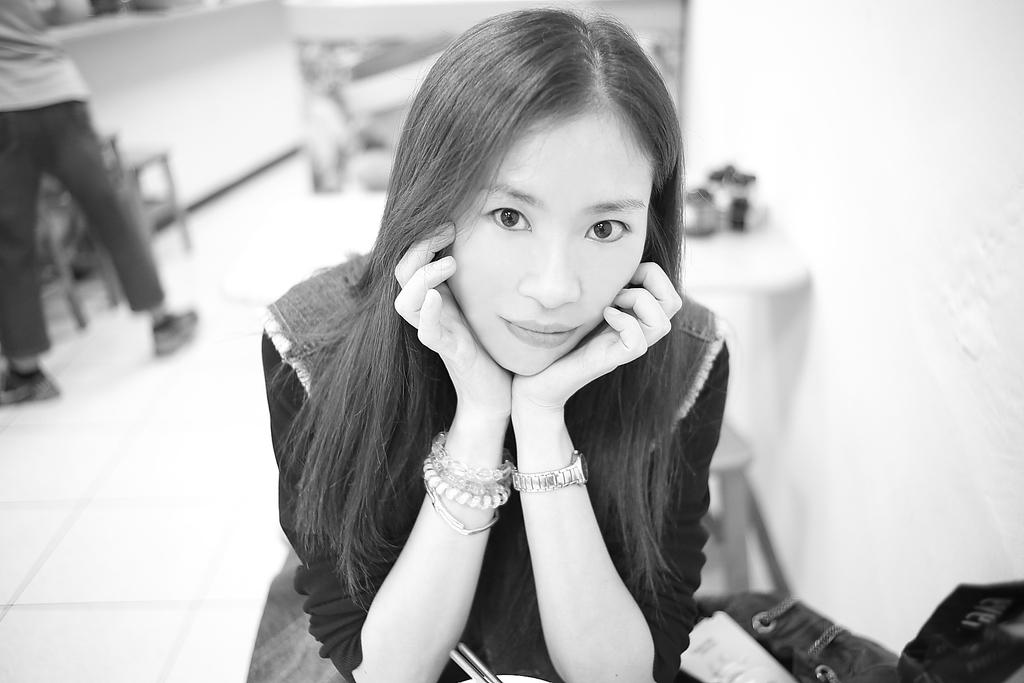Who is the main subject in the image? There is a girl in the center of the image. Can you describe the other person in the image? There is a man on the left side of the image. What can be observed about the background of the image? The background area of the image is blurred. What type of flowers can be seen in the image? There are no flowers present in the image. What time of day is depicted in the image? The time of day cannot be determined from the image, as there is no information about lighting or shadows. 